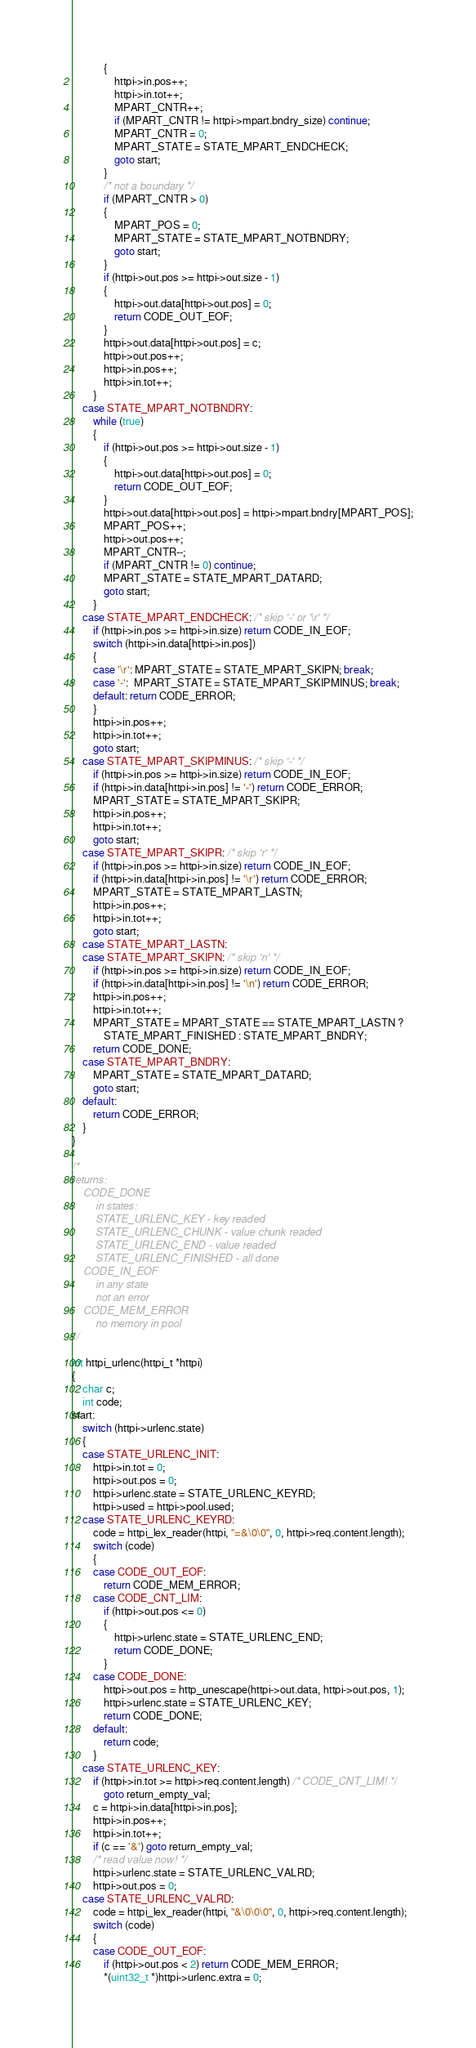<code> <loc_0><loc_0><loc_500><loc_500><_C_>            {
                httpi->in.pos++;
                httpi->in.tot++;
                MPART_CNTR++;
                if (MPART_CNTR != httpi->mpart.bndry_size) continue;
                MPART_CNTR = 0;
                MPART_STATE = STATE_MPART_ENDCHECK;
                goto start;
            }
            /* not a boundary */
            if (MPART_CNTR > 0)
            {
                MPART_POS = 0;
                MPART_STATE = STATE_MPART_NOTBNDRY;
                goto start;
            }
            if (httpi->out.pos >= httpi->out.size - 1)
            {
                httpi->out.data[httpi->out.pos] = 0;
                return CODE_OUT_EOF;
            }
            httpi->out.data[httpi->out.pos] = c;
            httpi->out.pos++;
            httpi->in.pos++;
            httpi->in.tot++;
        }
    case STATE_MPART_NOTBNDRY:
        while (true)
        {
            if (httpi->out.pos >= httpi->out.size - 1)
            {
                httpi->out.data[httpi->out.pos] = 0;
                return CODE_OUT_EOF;
            }
            httpi->out.data[httpi->out.pos] = httpi->mpart.bndry[MPART_POS];
            MPART_POS++;
            httpi->out.pos++;
            MPART_CNTR--;
            if (MPART_CNTR != 0) continue;
            MPART_STATE = STATE_MPART_DATARD;
            goto start;
        }
    case STATE_MPART_ENDCHECK: /* skip '-' or '\r' */
        if (httpi->in.pos >= httpi->in.size) return CODE_IN_EOF;
        switch (httpi->in.data[httpi->in.pos])
        {
        case '\r': MPART_STATE = STATE_MPART_SKIPN; break;
        case '-':  MPART_STATE = STATE_MPART_SKIPMINUS; break;
        default: return CODE_ERROR;
        }
        httpi->in.pos++;
        httpi->in.tot++;
        goto start;
    case STATE_MPART_SKIPMINUS: /* skip '-' */
        if (httpi->in.pos >= httpi->in.size) return CODE_IN_EOF;
        if (httpi->in.data[httpi->in.pos] != '-') return CODE_ERROR;
        MPART_STATE = STATE_MPART_SKIPR;
        httpi->in.pos++;
        httpi->in.tot++;
        goto start;
    case STATE_MPART_SKIPR: /* skip 'r' */
        if (httpi->in.pos >= httpi->in.size) return CODE_IN_EOF;
        if (httpi->in.data[httpi->in.pos] != '\r') return CODE_ERROR;
        MPART_STATE = STATE_MPART_LASTN;
        httpi->in.pos++;
        httpi->in.tot++;
        goto start;
    case STATE_MPART_LASTN:
    case STATE_MPART_SKIPN: /* skip 'n' */
        if (httpi->in.pos >= httpi->in.size) return CODE_IN_EOF;
        if (httpi->in.data[httpi->in.pos] != '\n') return CODE_ERROR;
        httpi->in.pos++;
        httpi->in.tot++;
        MPART_STATE = MPART_STATE == STATE_MPART_LASTN ?
            STATE_MPART_FINISHED : STATE_MPART_BNDRY;
        return CODE_DONE;
    case STATE_MPART_BNDRY:
        MPART_STATE = STATE_MPART_DATARD;
        goto start;
    default:
        return CODE_ERROR;
    }
}

/*
returns:
    CODE_DONE
        in states:
        STATE_URLENC_KEY - key readed
        STATE_URLENC_CHUNK - value chunk readed
        STATE_URLENC_END - value readed
        STATE_URLENC_FINISHED - all done
    CODE_IN_EOF
        in any state
        not an error
    CODE_MEM_ERROR
        no memory in pool
*/

int httpi_urlenc(httpi_t *httpi)
{
    char c;
    int code;
start:
    switch (httpi->urlenc.state)
    {
    case STATE_URLENC_INIT:
        httpi->in.tot = 0;
        httpi->out.pos = 0;
        httpi->urlenc.state = STATE_URLENC_KEYRD;
        httpi->used = httpi->pool.used;
    case STATE_URLENC_KEYRD:
        code = httpi_lex_reader(httpi, "=&\0\0", 0, httpi->req.content.length);
        switch (code)
        {
        case CODE_OUT_EOF:
            return CODE_MEM_ERROR;
        case CODE_CNT_LIM:
            if (httpi->out.pos <= 0)
            {
                httpi->urlenc.state = STATE_URLENC_END;
                return CODE_DONE;
            }
        case CODE_DONE:
            httpi->out.pos = http_unescape(httpi->out.data, httpi->out.pos, 1);
            httpi->urlenc.state = STATE_URLENC_KEY;
            return CODE_DONE;
        default:
            return code;
        }
    case STATE_URLENC_KEY:
        if (httpi->in.tot >= httpi->req.content.length) /* CODE_CNT_LIM! */
            goto return_empty_val;
        c = httpi->in.data[httpi->in.pos];
        httpi->in.pos++;
        httpi->in.tot++;
        if (c == '&') goto return_empty_val;
        /* read value now! */
        httpi->urlenc.state = STATE_URLENC_VALRD;
        httpi->out.pos = 0;
    case STATE_URLENC_VALRD:
        code = httpi_lex_reader(httpi, "&\0\0\0", 0, httpi->req.content.length);
        switch (code)
        {
        case CODE_OUT_EOF:
            if (httpi->out.pos < 2) return CODE_MEM_ERROR;
            *(uint32_t *)httpi->urlenc.extra = 0;</code> 